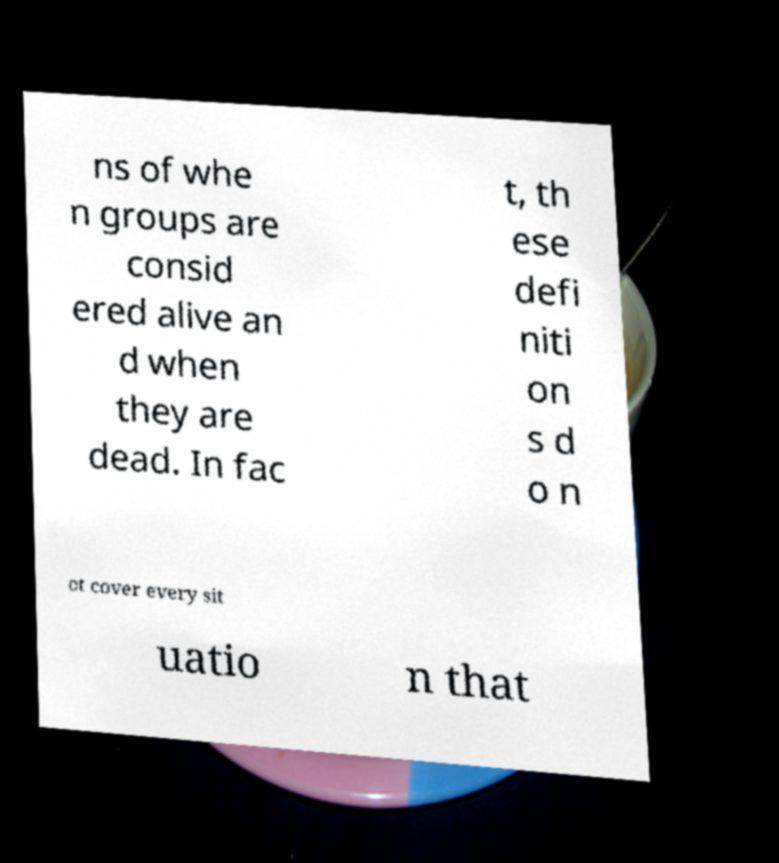Please read and relay the text visible in this image. What does it say? ns of whe n groups are consid ered alive an d when they are dead. In fac t, th ese defi niti on s d o n ot cover every sit uatio n that 